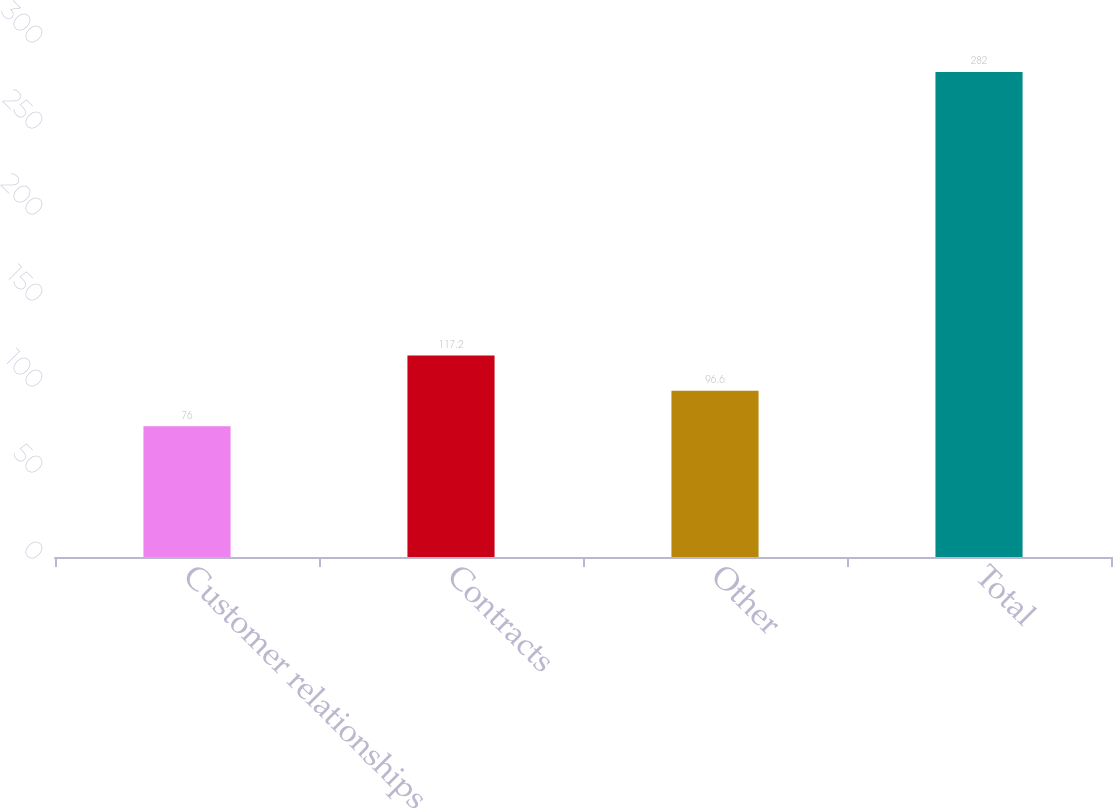Convert chart. <chart><loc_0><loc_0><loc_500><loc_500><bar_chart><fcel>Customer relationships<fcel>Contracts<fcel>Other<fcel>Total<nl><fcel>76<fcel>117.2<fcel>96.6<fcel>282<nl></chart> 